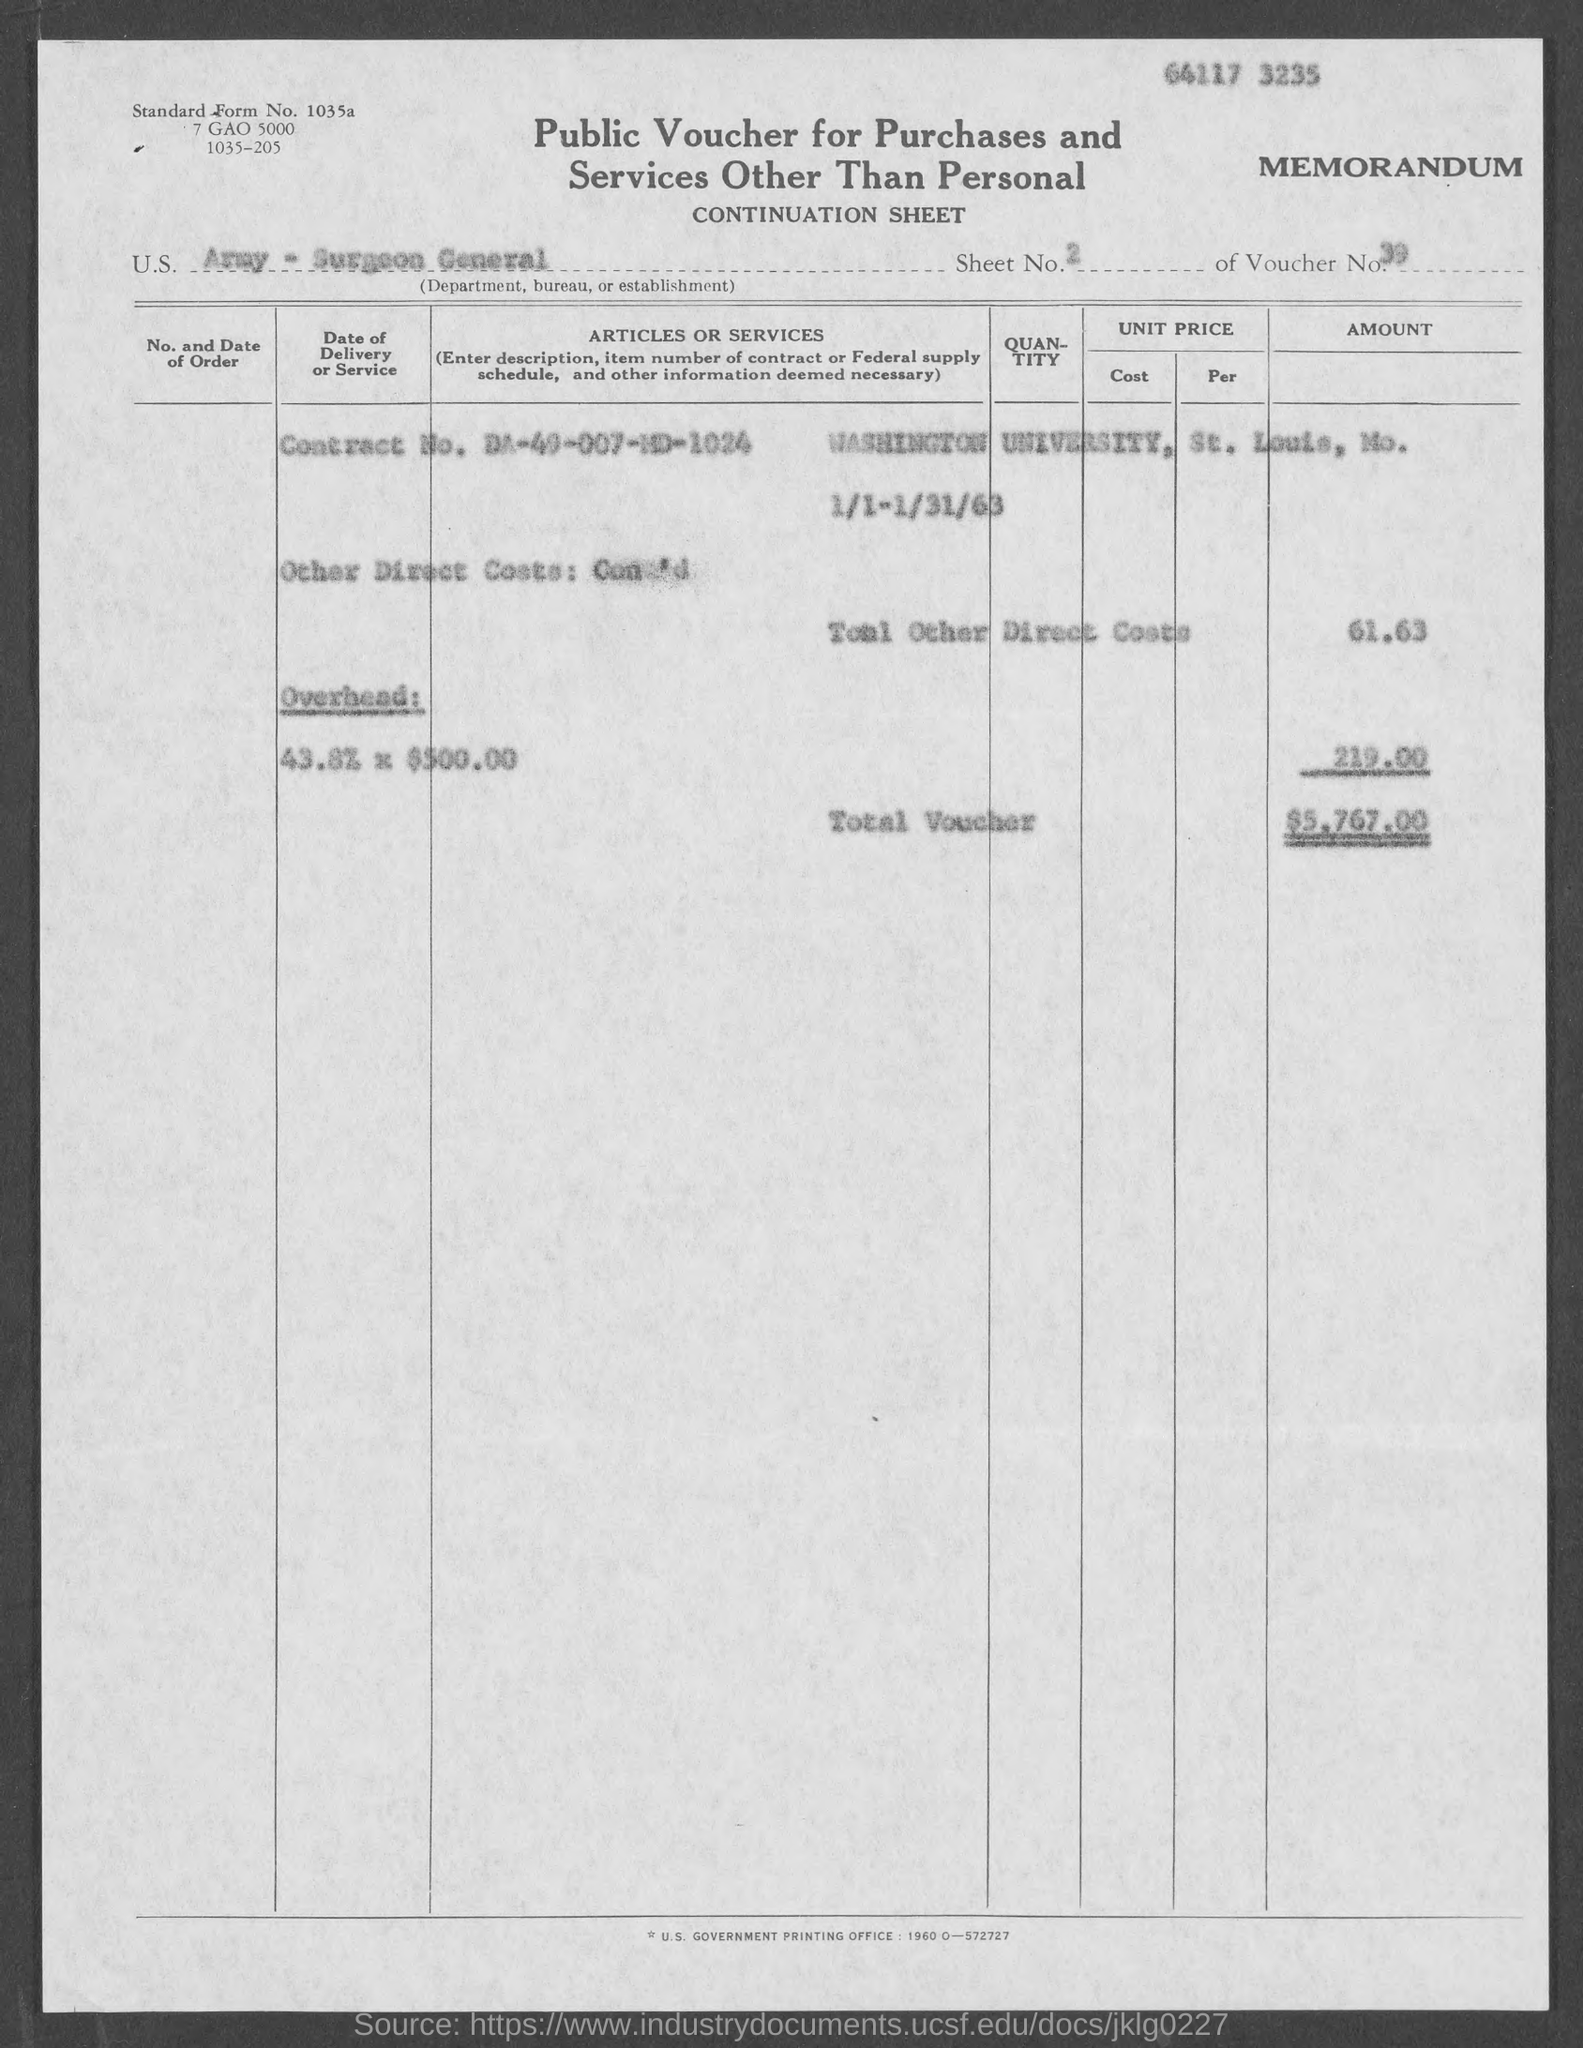Mention a couple of crucial points in this snapshot. The voucher number provided in the document is 39. The given voucher is a public voucher for the purchase of goods and services, excluding personal ones. The Contract No. given in the voucher is DA-49-007-MD-1024. The voucher indicates that the U.S. Department, Bureau, or Establishment mentioned is the Army - Surgeon General. The total voucher amount mentioned in the document is 5,767, 